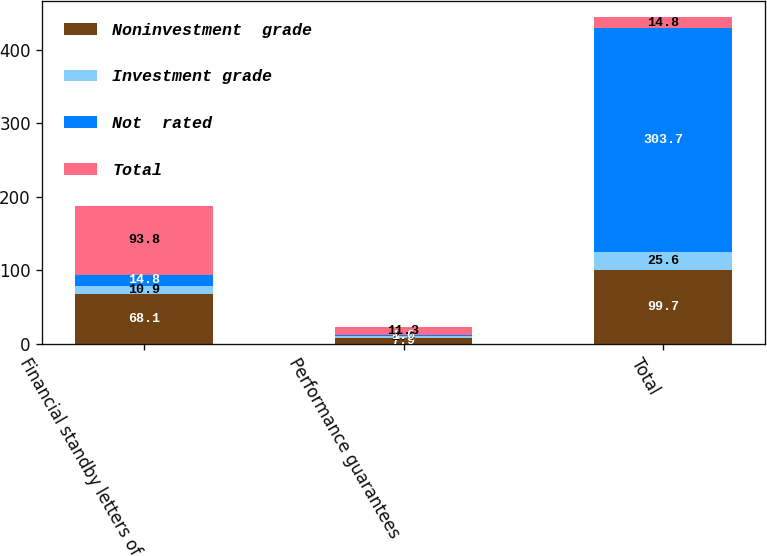<chart> <loc_0><loc_0><loc_500><loc_500><stacked_bar_chart><ecel><fcel>Financial standby letters of<fcel>Performance guarantees<fcel>Total<nl><fcel>Noninvestment  grade<fcel>68.1<fcel>7.9<fcel>99.7<nl><fcel>Investment grade<fcel>10.9<fcel>2.4<fcel>25.6<nl><fcel>Not  rated<fcel>14.8<fcel>1<fcel>303.7<nl><fcel>Total<fcel>93.8<fcel>11.3<fcel>14.8<nl></chart> 